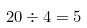Convert formula to latex. <formula><loc_0><loc_0><loc_500><loc_500>2 0 \div 4 = 5</formula> 